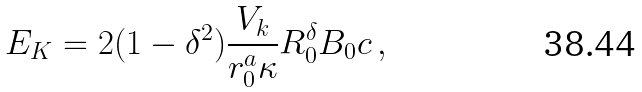Convert formula to latex. <formula><loc_0><loc_0><loc_500><loc_500>E _ { K } = 2 ( 1 - \delta ^ { 2 } ) \frac { V _ { k } } { r _ { 0 } ^ { a } \kappa } R _ { 0 } ^ { \delta } B _ { 0 } c \, ,</formula> 